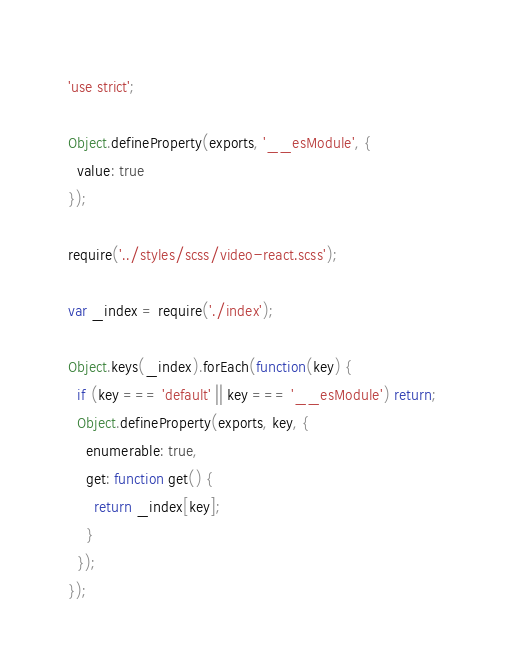Convert code to text. <code><loc_0><loc_0><loc_500><loc_500><_JavaScript_>'use strict';

Object.defineProperty(exports, '__esModule', {
  value: true
});

require('../styles/scss/video-react.scss');

var _index = require('./index');

Object.keys(_index).forEach(function(key) {
  if (key === 'default' || key === '__esModule') return;
  Object.defineProperty(exports, key, {
    enumerable: true,
    get: function get() {
      return _index[key];
    }
  });
});
</code> 